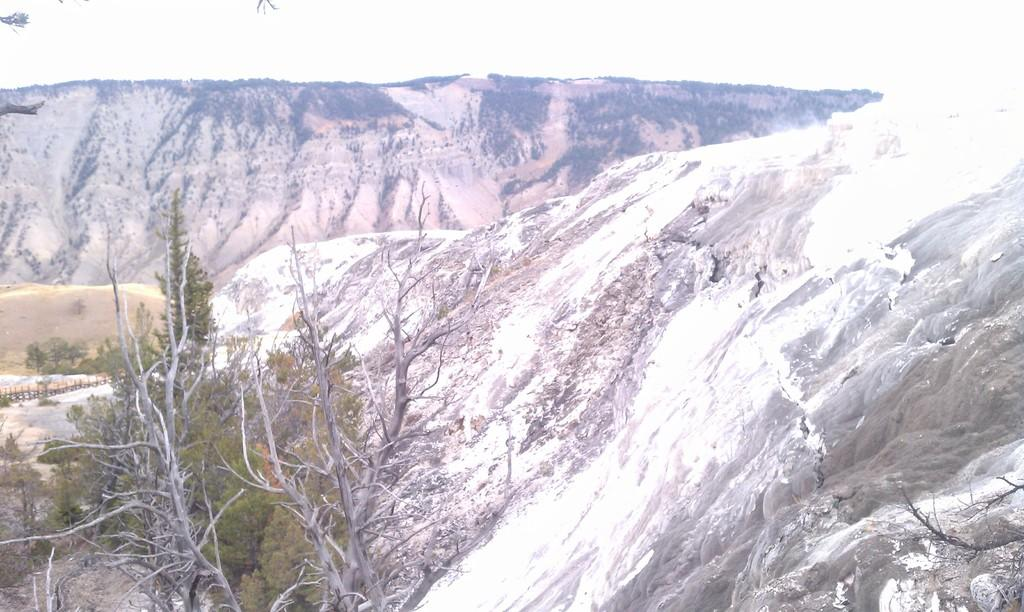What type of natural landform can be seen in the image? There are mountains in the image. What type of vegetation is present in the image? There are trees in the image. Can you see a pipe sticking out of the mountain in the image? There is no pipe visible in the image; it only features mountains and trees. Is there a giraffe grazing among the trees in the image? There is no giraffe present in the image; it only features mountains and trees. 